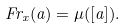<formula> <loc_0><loc_0><loc_500><loc_500>F r _ { x } ( a ) = \mu ( [ a ] ) .</formula> 